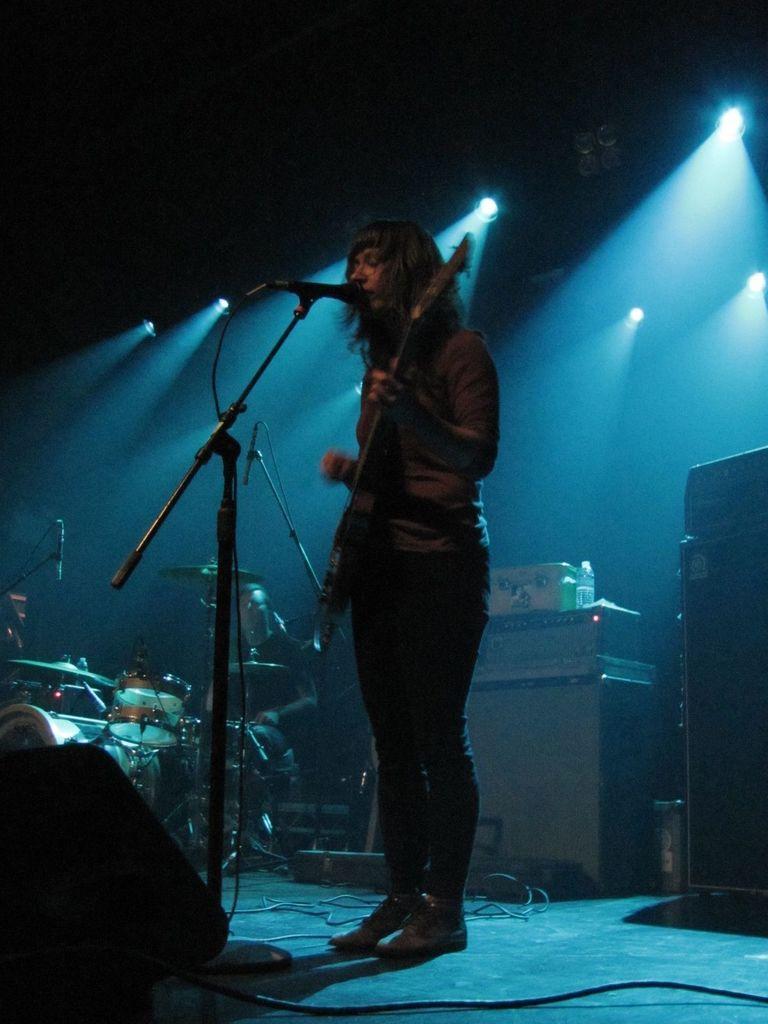Please provide a concise description of this image. In this image i can see i can see a man is standing and playing a guitar in front of a microphone. 